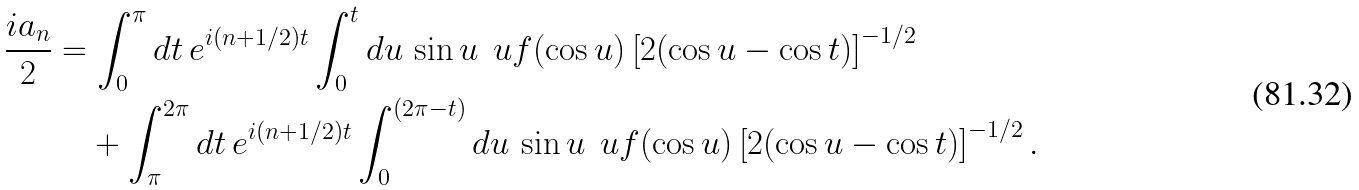Convert formula to latex. <formula><loc_0><loc_0><loc_500><loc_500>\frac { i a _ { n } } { 2 } & = \int _ { 0 } ^ { \pi } d t \, e ^ { i ( n + 1 / 2 ) t } \int _ { 0 } ^ { t } d u \, \sin u \, \ u f ( \cos u ) \left [ 2 ( \cos u - \cos t ) \right ] ^ { - 1 / 2 } \\ & \quad + \int _ { \pi } ^ { 2 \pi } d t \, e ^ { i ( n + 1 / 2 ) t } \int _ { 0 } ^ { ( 2 \pi - t ) } d u \, \sin u \, \ u f ( \cos u ) \left [ 2 ( \cos u - \cos t ) \right ] ^ { - 1 / 2 } .</formula> 